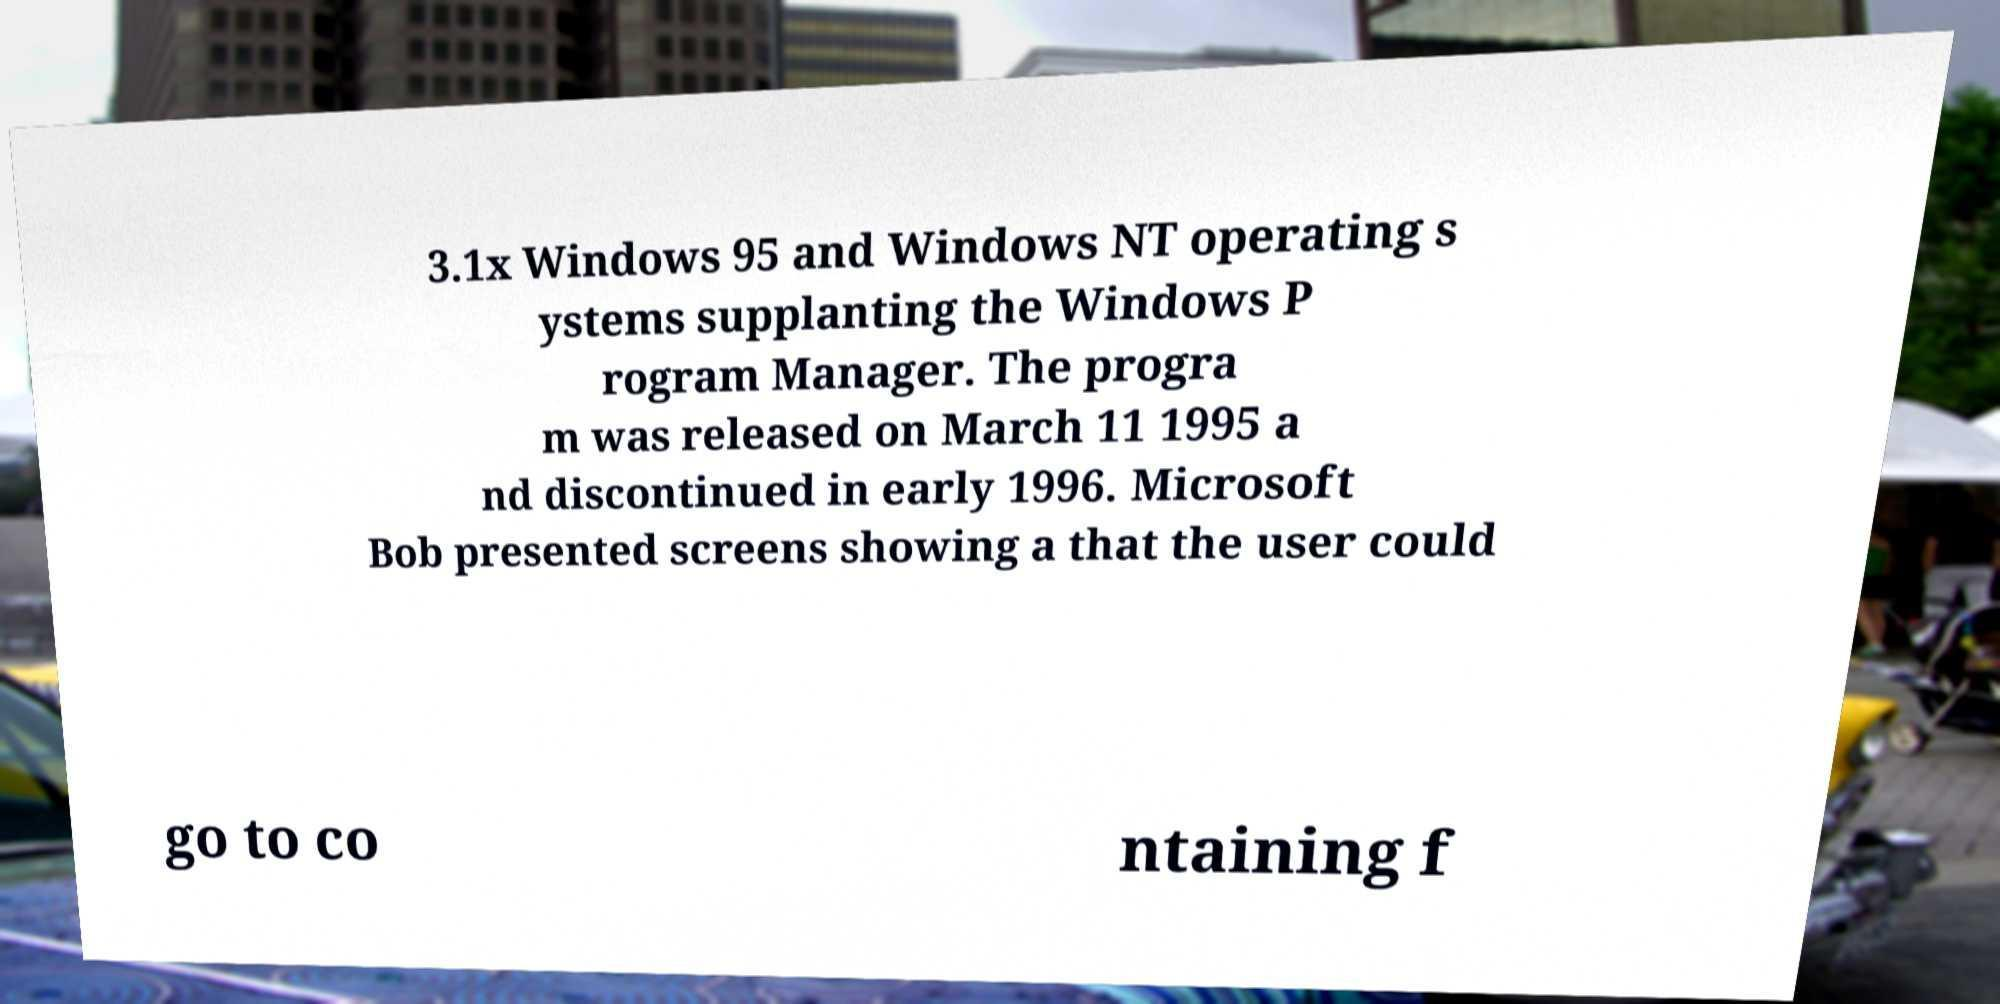Could you extract and type out the text from this image? 3.1x Windows 95 and Windows NT operating s ystems supplanting the Windows P rogram Manager. The progra m was released on March 11 1995 a nd discontinued in early 1996. Microsoft Bob presented screens showing a that the user could go to co ntaining f 